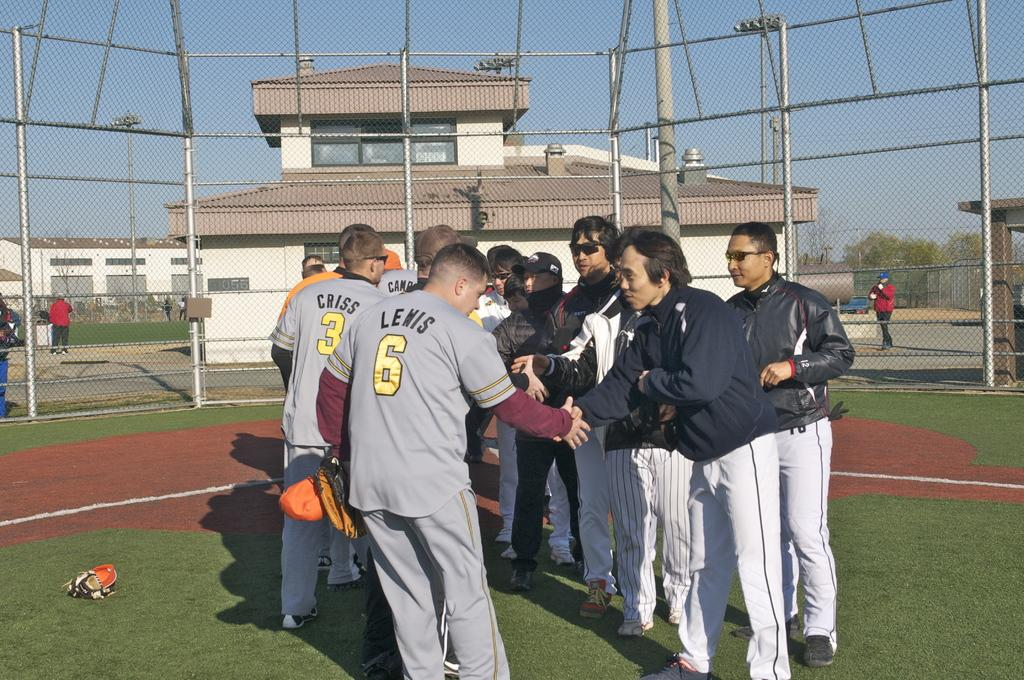<image>
Give a short and clear explanation of the subsequent image. Player number six, with Lewis on the back of his shirt, shakes hand with another man. 